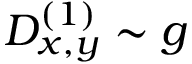Convert formula to latex. <formula><loc_0><loc_0><loc_500><loc_500>D _ { x , y } ^ { ( 1 ) } \sim g</formula> 